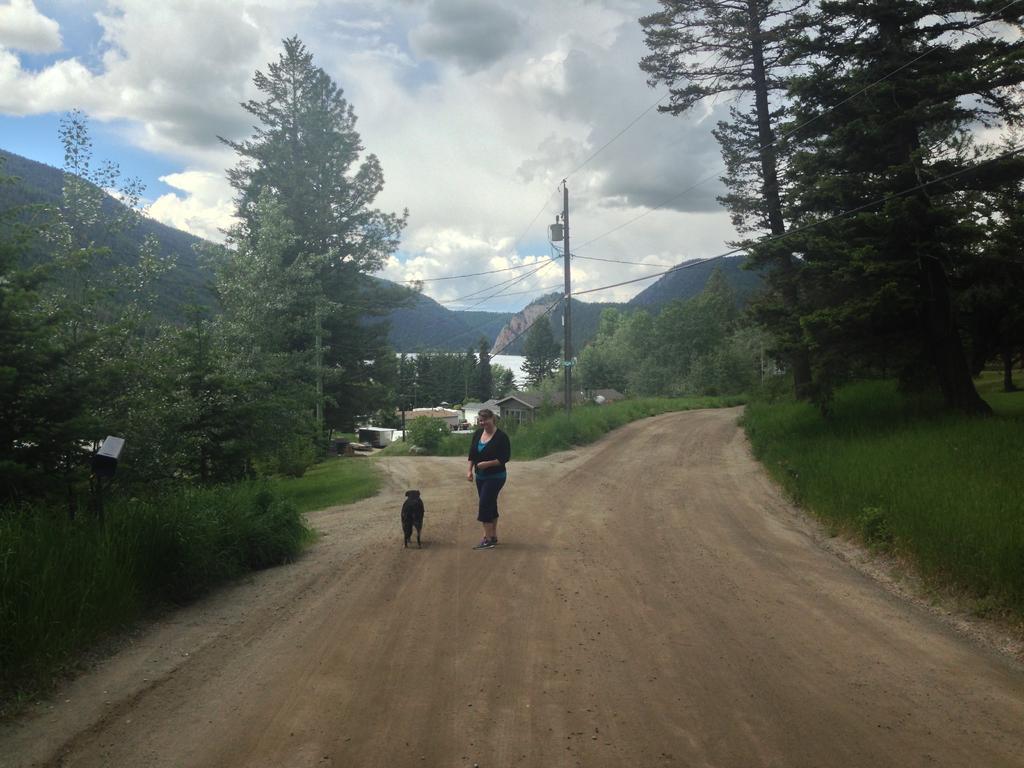In one or two sentences, can you explain what this image depicts? In this image there is a lady, beside her there is a dog on the road. On the right and left side of the image there are trees, plants. At the center there are some houses and one utility pole. In the background there are mountains and a sky. 